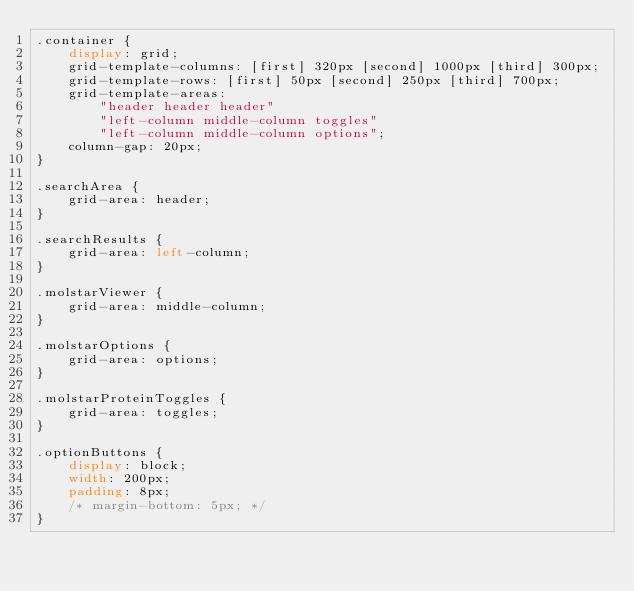<code> <loc_0><loc_0><loc_500><loc_500><_CSS_>.container {
    display: grid;
    grid-template-columns: [first] 320px [second] 1000px [third] 300px;
    grid-template-rows: [first] 50px [second] 250px [third] 700px;
    grid-template-areas:
        "header header header"
        "left-column middle-column toggles"
        "left-column middle-column options";
    column-gap: 20px;
}

.searchArea {
    grid-area: header;
}

.searchResults {
    grid-area: left-column;
}

.molstarViewer {
    grid-area: middle-column;
}

.molstarOptions {
    grid-area: options;
}

.molstarProteinToggles {
    grid-area: toggles;
}

.optionButtons {
    display: block;
    width: 200px;
    padding: 8px;
    /* margin-bottom: 5px; */
}
</code> 